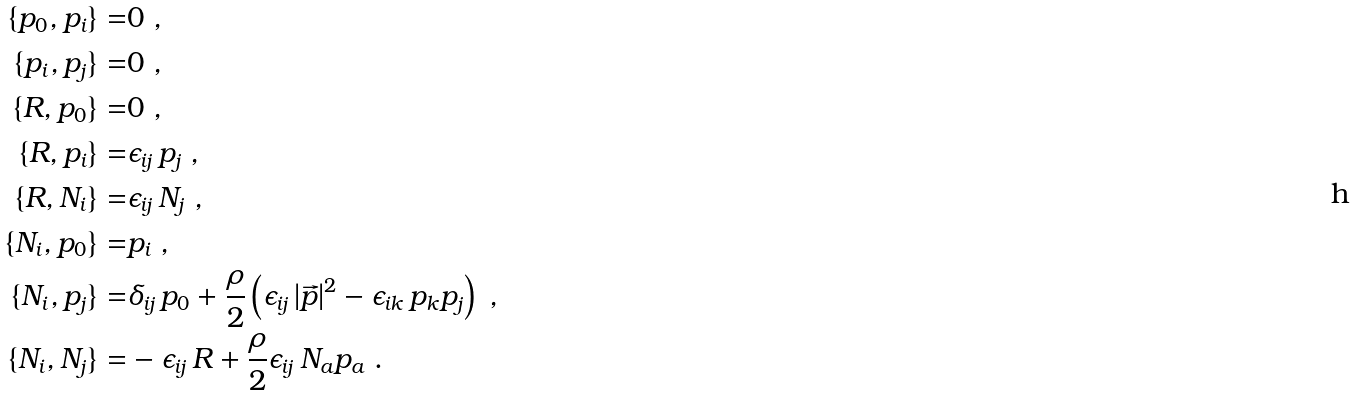Convert formula to latex. <formula><loc_0><loc_0><loc_500><loc_500>\{ p _ { 0 } , p _ { i } \} = & 0 \ , \\ \{ p _ { i } , p _ { j } \} = & 0 \ , \\ \{ R , p _ { 0 } \} = & 0 \ , \\ \{ R , p _ { i } \} = & \epsilon _ { i j } \, p _ { j } \ , \\ \{ R , N _ { i } \} = & \epsilon _ { i j } \, N _ { j } \ , \\ \{ N _ { i } , p _ { 0 } \} = & p _ { i } \ , \\ \{ N _ { i } , p _ { j } \} = & \delta _ { i j } \, p _ { 0 } + \frac { \rho } { 2 } \left ( \epsilon _ { i j } \, | \vec { p } | ^ { 2 } - \epsilon _ { i k } \, p _ { k } p _ { j } \right ) \ , \\ \{ N _ { i } , N _ { j } \} = & - \epsilon _ { i j } \, R + \frac { \rho } { 2 } \epsilon _ { i j } \, N _ { a } p _ { a } \ .</formula> 